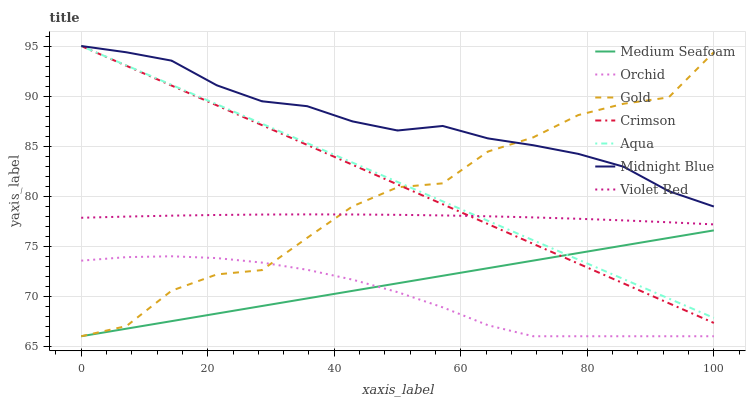Does Gold have the minimum area under the curve?
Answer yes or no. No. Does Gold have the maximum area under the curve?
Answer yes or no. No. Is Midnight Blue the smoothest?
Answer yes or no. No. Is Midnight Blue the roughest?
Answer yes or no. No. Does Midnight Blue have the lowest value?
Answer yes or no. No. Does Gold have the highest value?
Answer yes or no. No. Is Medium Seafoam less than Violet Red?
Answer yes or no. Yes. Is Crimson greater than Orchid?
Answer yes or no. Yes. Does Medium Seafoam intersect Violet Red?
Answer yes or no. No. 